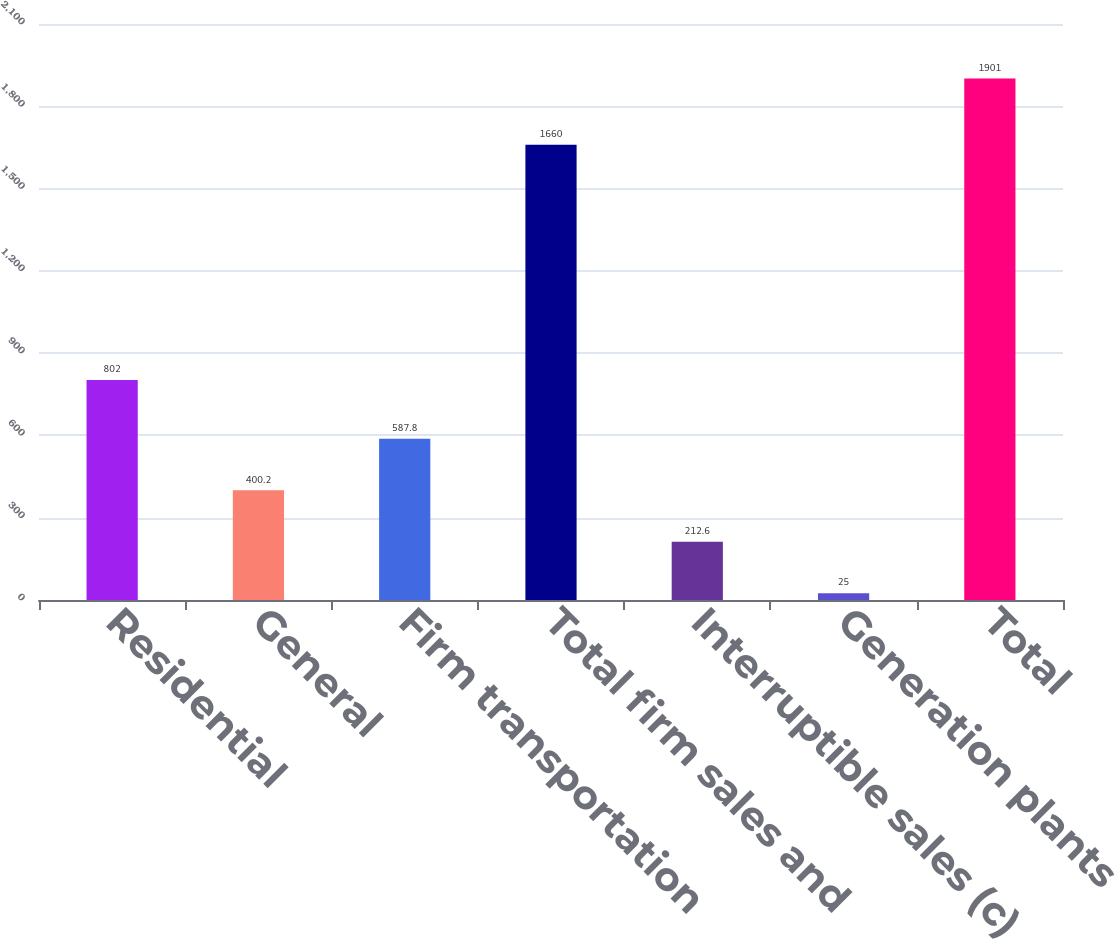Convert chart to OTSL. <chart><loc_0><loc_0><loc_500><loc_500><bar_chart><fcel>Residential<fcel>General<fcel>Firm transportation<fcel>Total firm sales and<fcel>Interruptible sales (c)<fcel>Generation plants<fcel>Total<nl><fcel>802<fcel>400.2<fcel>587.8<fcel>1660<fcel>212.6<fcel>25<fcel>1901<nl></chart> 